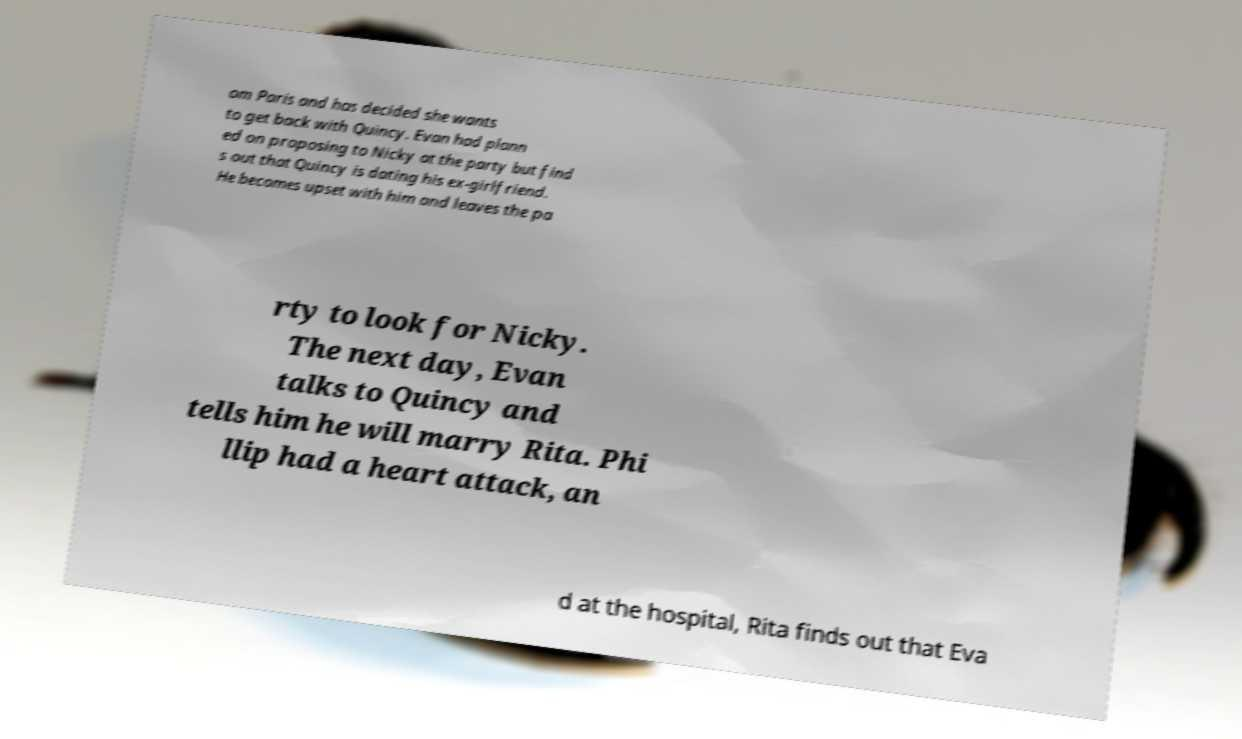Please read and relay the text visible in this image. What does it say? om Paris and has decided she wants to get back with Quincy. Evan had plann ed on proposing to Nicky at the party but find s out that Quincy is dating his ex-girlfriend. He becomes upset with him and leaves the pa rty to look for Nicky. The next day, Evan talks to Quincy and tells him he will marry Rita. Phi llip had a heart attack, an d at the hospital, Rita finds out that Eva 